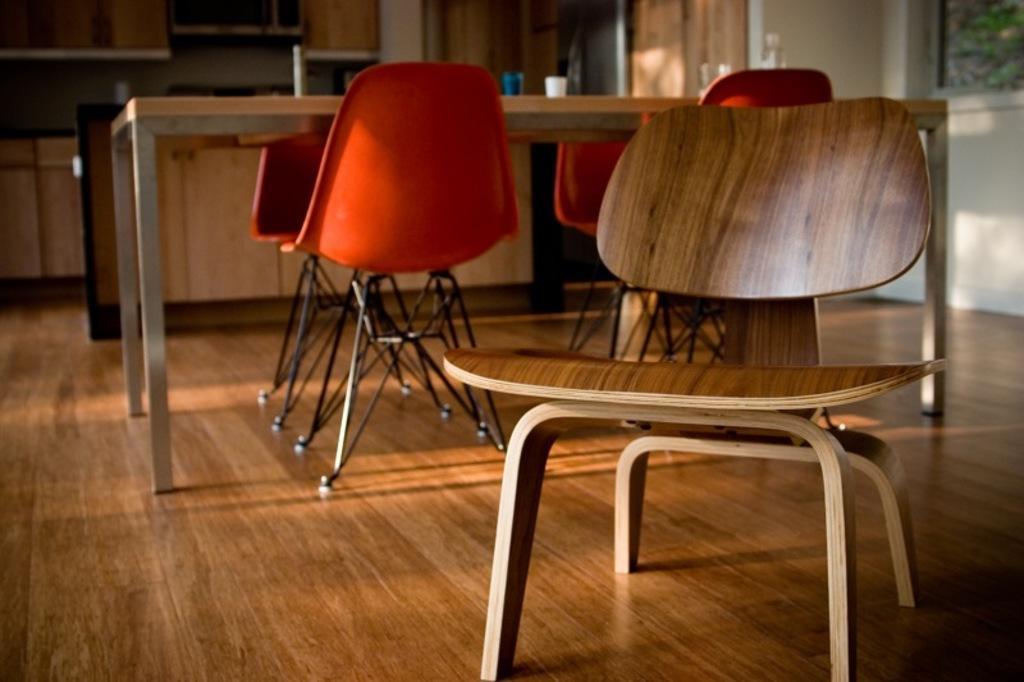Can you describe this image briefly? In this image there is a wooden chair in the foreground. In the background there is a table and there are four chairs around it. On the table there are two cups. At the bottom there is a wooden floor. 